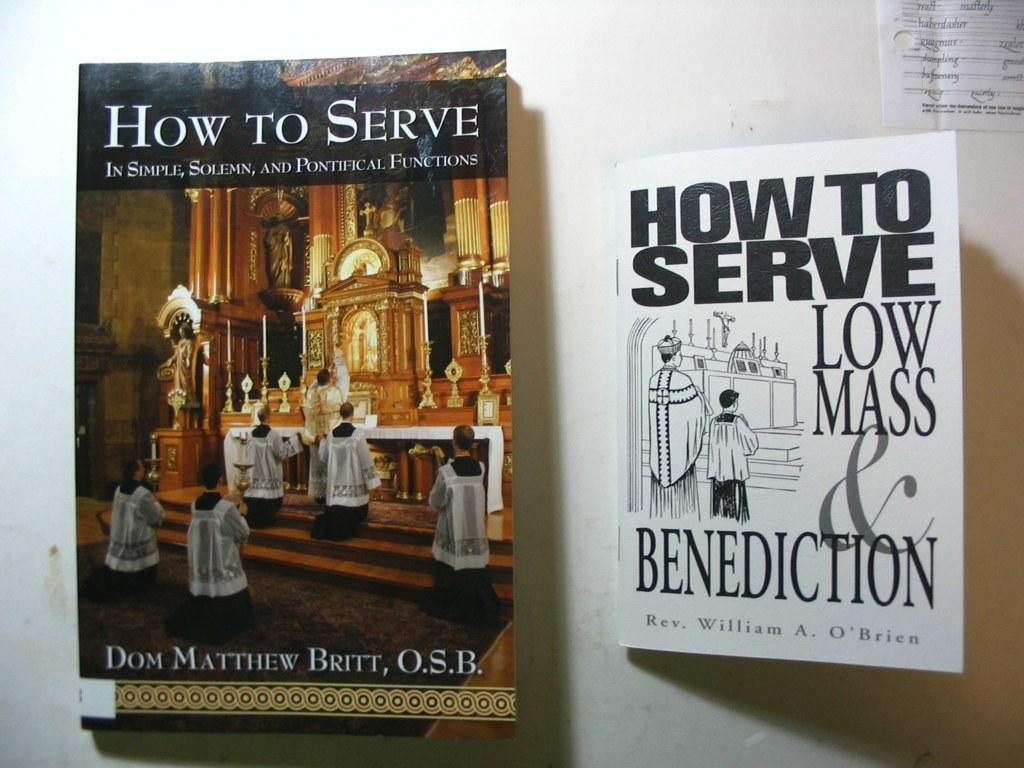<image>
Write a terse but informative summary of the picture. A pair of books offer instruction on serving low mass and benediction. 